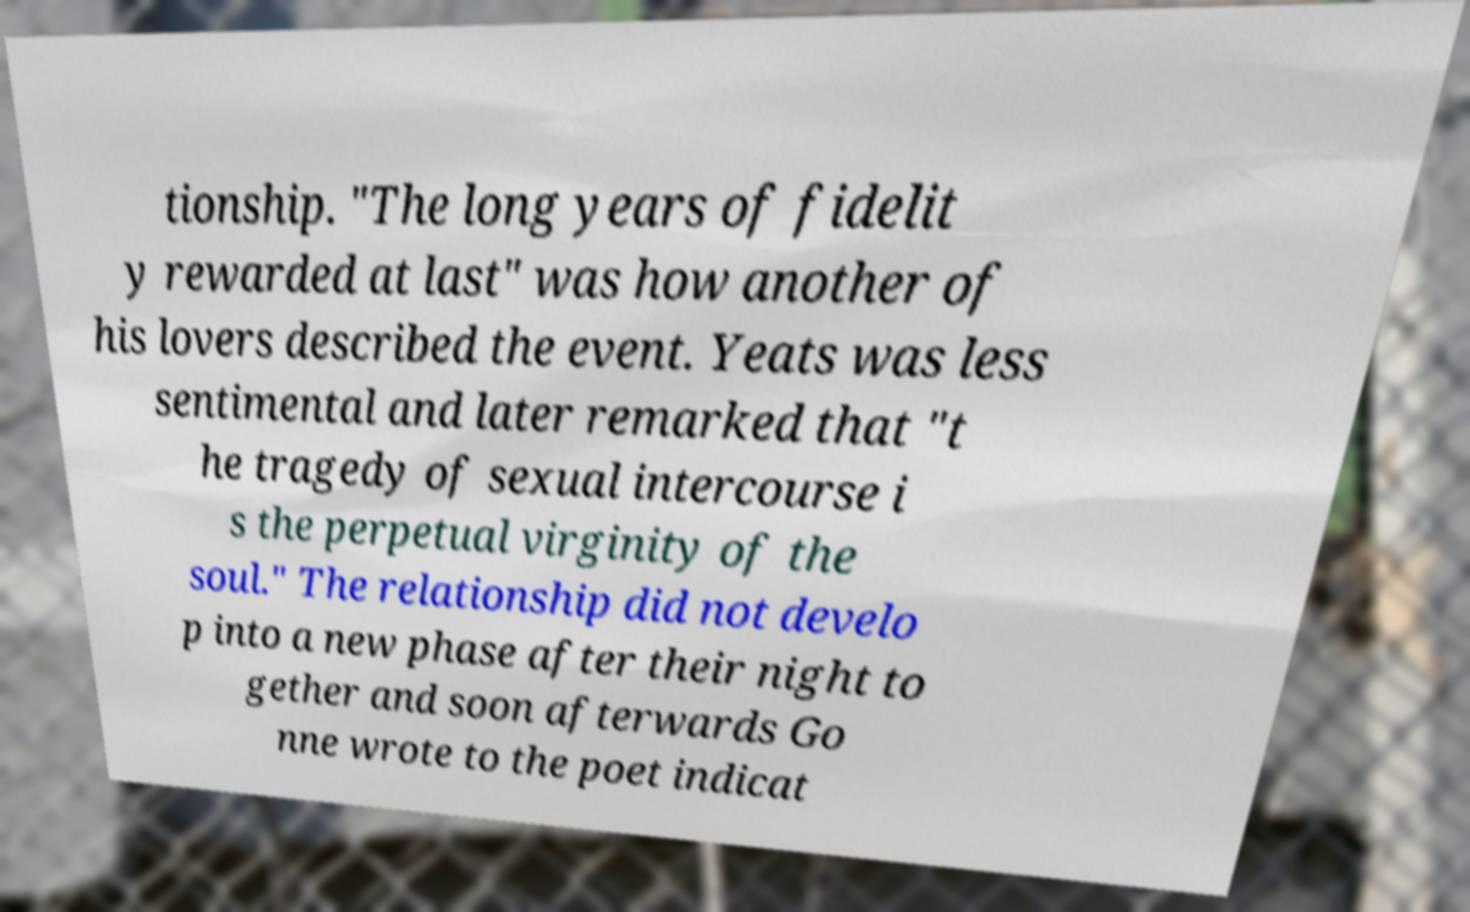There's text embedded in this image that I need extracted. Can you transcribe it verbatim? tionship. "The long years of fidelit y rewarded at last" was how another of his lovers described the event. Yeats was less sentimental and later remarked that "t he tragedy of sexual intercourse i s the perpetual virginity of the soul." The relationship did not develo p into a new phase after their night to gether and soon afterwards Go nne wrote to the poet indicat 